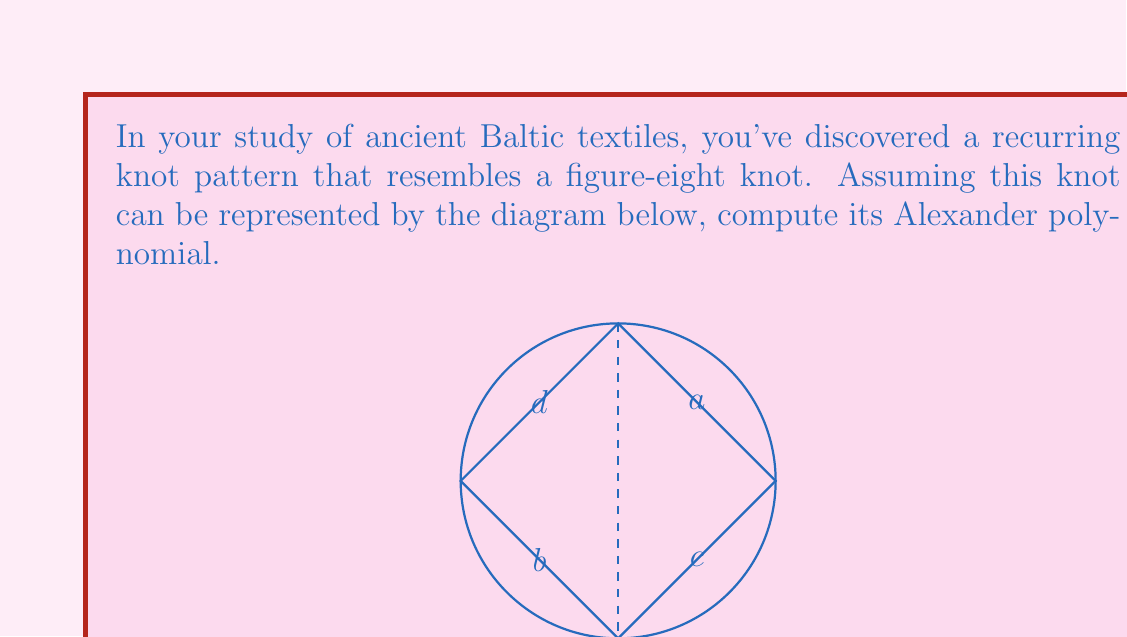Give your solution to this math problem. To compute the Alexander polynomial for this knot, we'll follow these steps:

1) First, we need to label the arcs and crossings. We've already labeled the arcs a, b, c, and d in the diagram.

2) Now, we'll create a system of linear equations based on the crossings:

   At the top-right crossing: $a - tb + (t-1)d = 0$
   At the bottom-left crossing: $c - td + (t-1)b = 0$

3) We can represent this system as a matrix:

   $$\begin{pmatrix}
   1 & -t & 0 & t-1 \\
   0 & t-1 & 1 & -t
   \end{pmatrix}$$

4) The Alexander polynomial is the determinant of any (n-1) x (n-1) submatrix of this matrix, where n is the number of arcs. Let's choose the submatrix by removing the last column:

   $$\begin{vmatrix}
   1 & -t & 0 \\
   0 & t-1 & 1
   \end{vmatrix}$$

5) Calculate the determinant:
   $\Delta(t) = 1(t-1) - (-t)(0) = t - 1$

6) The final step is to normalize the polynomial. The Alexander polynomial is only defined up to multiplication by $\pm t^k$, where k is an integer. We want the lowest degree term to be positive and the polynomial to be symmetric. In this case, $t - 1$ is already in its normalized form.

Therefore, the Alexander polynomial for this figure-eight knot pattern is $\Delta(t) = t - 1$.
Answer: $\Delta(t) = t - 1$ 